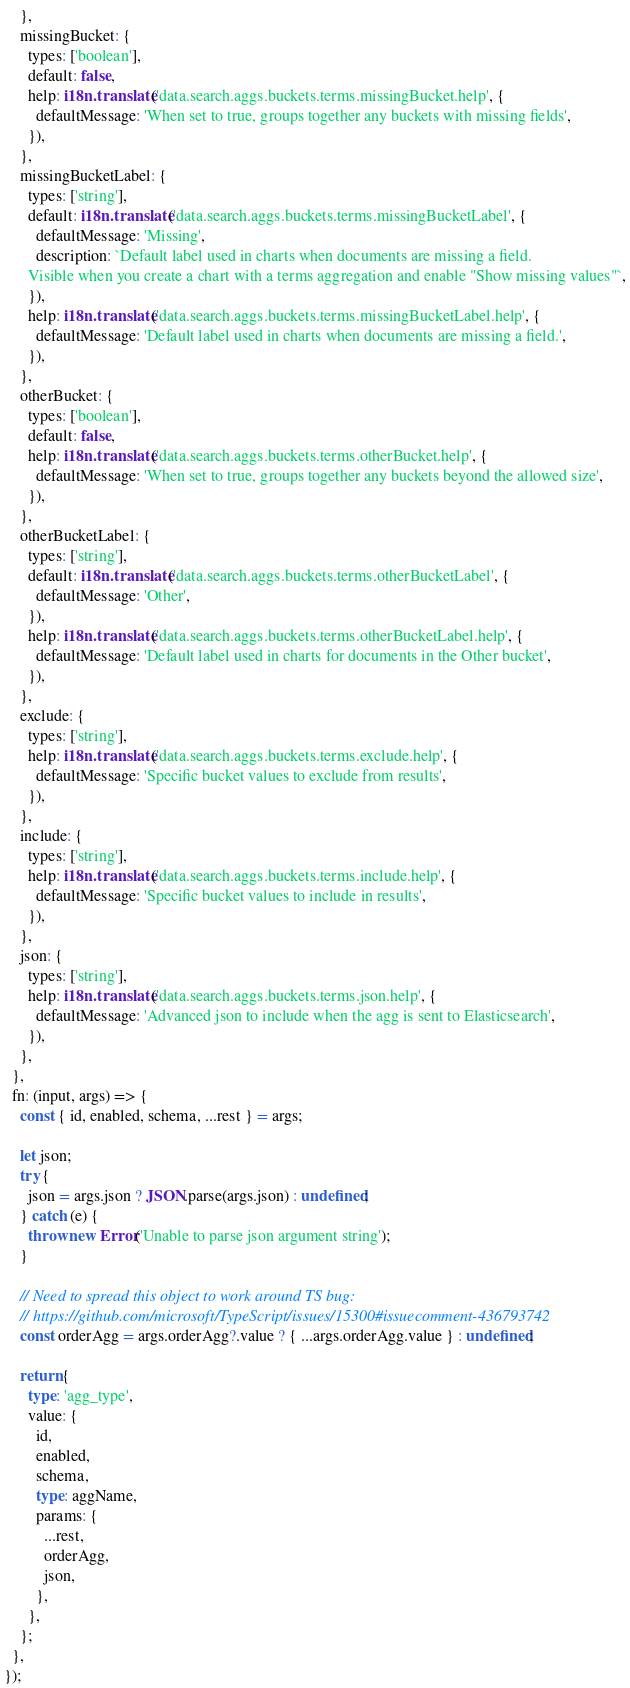<code> <loc_0><loc_0><loc_500><loc_500><_TypeScript_>    },
    missingBucket: {
      types: ['boolean'],
      default: false,
      help: i18n.translate('data.search.aggs.buckets.terms.missingBucket.help', {
        defaultMessage: 'When set to true, groups together any buckets with missing fields',
      }),
    },
    missingBucketLabel: {
      types: ['string'],
      default: i18n.translate('data.search.aggs.buckets.terms.missingBucketLabel', {
        defaultMessage: 'Missing',
        description: `Default label used in charts when documents are missing a field.
      Visible when you create a chart with a terms aggregation and enable "Show missing values"`,
      }),
      help: i18n.translate('data.search.aggs.buckets.terms.missingBucketLabel.help', {
        defaultMessage: 'Default label used in charts when documents are missing a field.',
      }),
    },
    otherBucket: {
      types: ['boolean'],
      default: false,
      help: i18n.translate('data.search.aggs.buckets.terms.otherBucket.help', {
        defaultMessage: 'When set to true, groups together any buckets beyond the allowed size',
      }),
    },
    otherBucketLabel: {
      types: ['string'],
      default: i18n.translate('data.search.aggs.buckets.terms.otherBucketLabel', {
        defaultMessage: 'Other',
      }),
      help: i18n.translate('data.search.aggs.buckets.terms.otherBucketLabel.help', {
        defaultMessage: 'Default label used in charts for documents in the Other bucket',
      }),
    },
    exclude: {
      types: ['string'],
      help: i18n.translate('data.search.aggs.buckets.terms.exclude.help', {
        defaultMessage: 'Specific bucket values to exclude from results',
      }),
    },
    include: {
      types: ['string'],
      help: i18n.translate('data.search.aggs.buckets.terms.include.help', {
        defaultMessage: 'Specific bucket values to include in results',
      }),
    },
    json: {
      types: ['string'],
      help: i18n.translate('data.search.aggs.buckets.terms.json.help', {
        defaultMessage: 'Advanced json to include when the agg is sent to Elasticsearch',
      }),
    },
  },
  fn: (input, args) => {
    const { id, enabled, schema, ...rest } = args;

    let json;
    try {
      json = args.json ? JSON.parse(args.json) : undefined;
    } catch (e) {
      throw new Error('Unable to parse json argument string');
    }

    // Need to spread this object to work around TS bug:
    // https://github.com/microsoft/TypeScript/issues/15300#issuecomment-436793742
    const orderAgg = args.orderAgg?.value ? { ...args.orderAgg.value } : undefined;

    return {
      type: 'agg_type',
      value: {
        id,
        enabled,
        schema,
        type: aggName,
        params: {
          ...rest,
          orderAgg,
          json,
        },
      },
    };
  },
});
</code> 